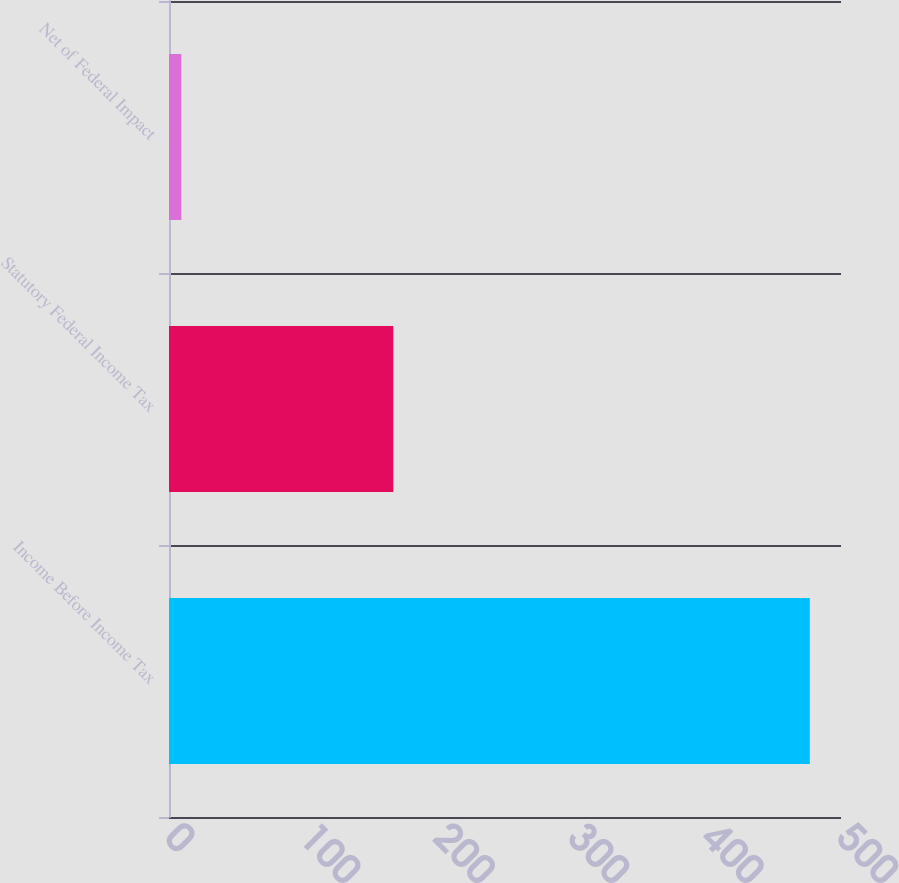<chart> <loc_0><loc_0><loc_500><loc_500><bar_chart><fcel>Income Before Income Tax<fcel>Statutory Federal Income Tax<fcel>Net of Federal Impact<nl><fcel>476.8<fcel>166.9<fcel>9.2<nl></chart> 